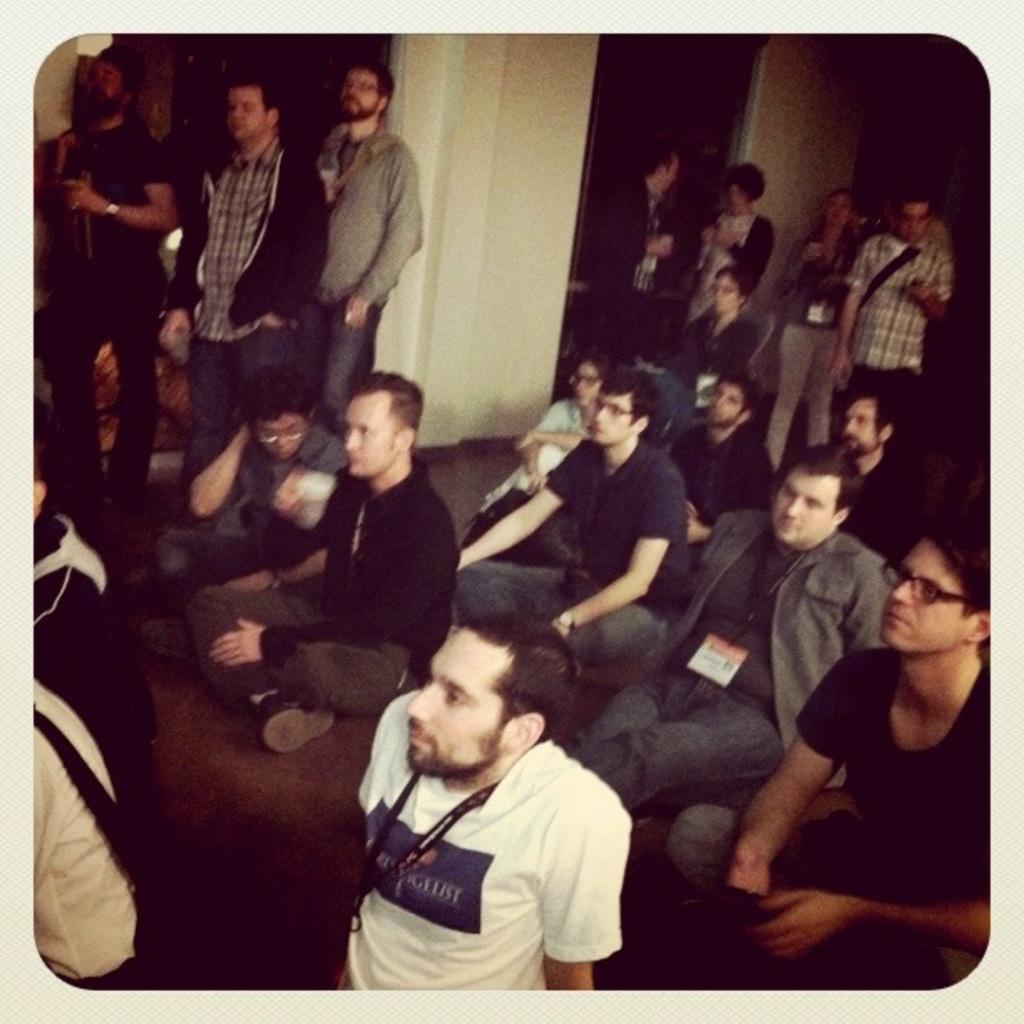What are the people in the image doing? There are people sitting on the floor and standing in the image. Can you describe the background of the image? There is a pillar in the background of the image. What type of quilt is being used by the donkey in the image? There is no donkey or quilt present in the image. 